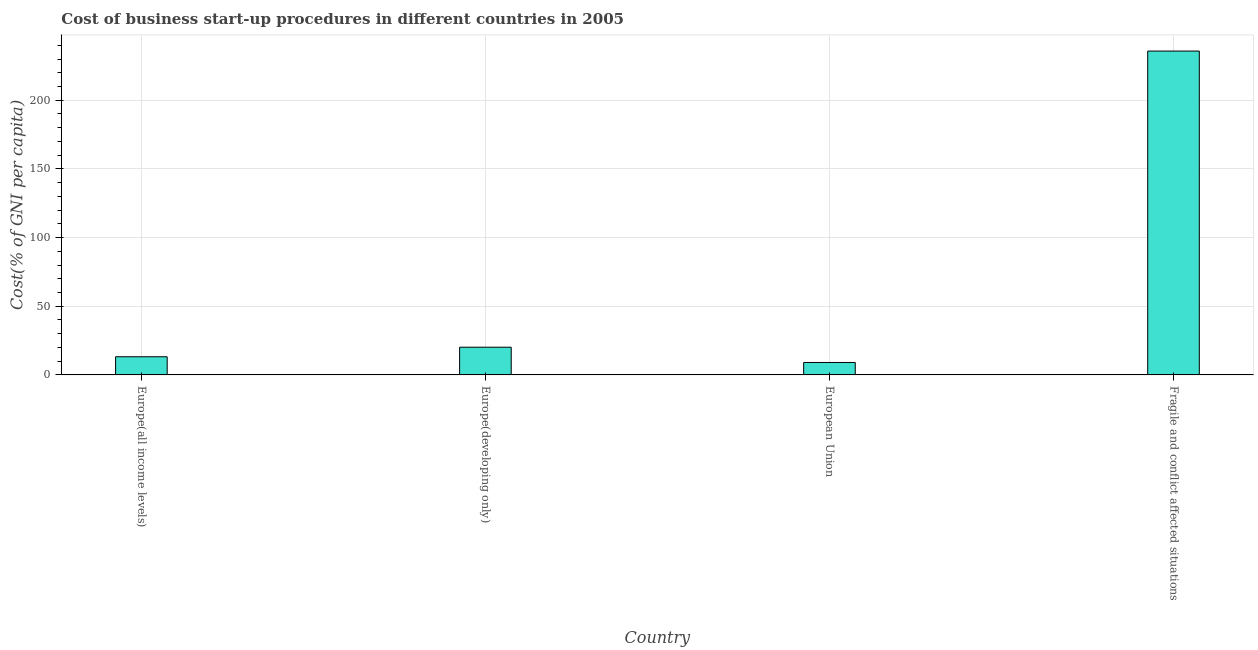Does the graph contain any zero values?
Offer a terse response. No. What is the title of the graph?
Give a very brief answer. Cost of business start-up procedures in different countries in 2005. What is the label or title of the Y-axis?
Your answer should be compact. Cost(% of GNI per capita). What is the cost of business startup procedures in Europe(all income levels)?
Your response must be concise. 13.22. Across all countries, what is the maximum cost of business startup procedures?
Provide a short and direct response. 235.78. Across all countries, what is the minimum cost of business startup procedures?
Ensure brevity in your answer.  9.05. In which country was the cost of business startup procedures maximum?
Your answer should be compact. Fragile and conflict affected situations. What is the sum of the cost of business startup procedures?
Your answer should be compact. 278.23. What is the difference between the cost of business startup procedures in Europe(all income levels) and Fragile and conflict affected situations?
Your response must be concise. -222.56. What is the average cost of business startup procedures per country?
Your response must be concise. 69.56. What is the median cost of business startup procedures?
Give a very brief answer. 16.7. What is the ratio of the cost of business startup procedures in Europe(developing only) to that in European Union?
Your response must be concise. 2.23. Is the difference between the cost of business startup procedures in Europe(developing only) and Fragile and conflict affected situations greater than the difference between any two countries?
Your response must be concise. No. What is the difference between the highest and the second highest cost of business startup procedures?
Make the answer very short. 215.61. Is the sum of the cost of business startup procedures in Europe(developing only) and Fragile and conflict affected situations greater than the maximum cost of business startup procedures across all countries?
Offer a terse response. Yes. What is the difference between the highest and the lowest cost of business startup procedures?
Keep it short and to the point. 226.73. How many bars are there?
Your response must be concise. 4. Are all the bars in the graph horizontal?
Make the answer very short. No. How many countries are there in the graph?
Keep it short and to the point. 4. What is the Cost(% of GNI per capita) of Europe(all income levels)?
Your answer should be compact. 13.22. What is the Cost(% of GNI per capita) of Europe(developing only)?
Your response must be concise. 20.17. What is the Cost(% of GNI per capita) in European Union?
Make the answer very short. 9.05. What is the Cost(% of GNI per capita) in Fragile and conflict affected situations?
Your answer should be very brief. 235.78. What is the difference between the Cost(% of GNI per capita) in Europe(all income levels) and Europe(developing only)?
Give a very brief answer. -6.95. What is the difference between the Cost(% of GNI per capita) in Europe(all income levels) and European Union?
Keep it short and to the point. 4.17. What is the difference between the Cost(% of GNI per capita) in Europe(all income levels) and Fragile and conflict affected situations?
Your answer should be very brief. -222.56. What is the difference between the Cost(% of GNI per capita) in Europe(developing only) and European Union?
Offer a terse response. 11.12. What is the difference between the Cost(% of GNI per capita) in Europe(developing only) and Fragile and conflict affected situations?
Ensure brevity in your answer.  -215.61. What is the difference between the Cost(% of GNI per capita) in European Union and Fragile and conflict affected situations?
Your response must be concise. -226.73. What is the ratio of the Cost(% of GNI per capita) in Europe(all income levels) to that in Europe(developing only)?
Provide a short and direct response. 0.66. What is the ratio of the Cost(% of GNI per capita) in Europe(all income levels) to that in European Union?
Offer a very short reply. 1.46. What is the ratio of the Cost(% of GNI per capita) in Europe(all income levels) to that in Fragile and conflict affected situations?
Offer a terse response. 0.06. What is the ratio of the Cost(% of GNI per capita) in Europe(developing only) to that in European Union?
Make the answer very short. 2.23. What is the ratio of the Cost(% of GNI per capita) in Europe(developing only) to that in Fragile and conflict affected situations?
Your answer should be compact. 0.09. What is the ratio of the Cost(% of GNI per capita) in European Union to that in Fragile and conflict affected situations?
Keep it short and to the point. 0.04. 